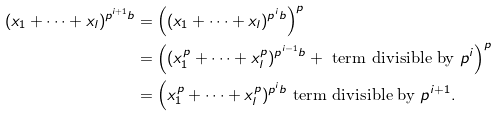<formula> <loc_0><loc_0><loc_500><loc_500>( x _ { 1 } + \cdots + x _ { l } ) ^ { p ^ { i + 1 } b } & = \Big ( ( x _ { 1 } + \cdots + x _ { l } ) ^ { p ^ { i } b } \Big ) ^ { p } \\ & = \Big ( ( x _ { 1 } ^ { p } + \cdots + x _ { l } ^ { p } ) ^ { p ^ { i - 1 } b } + \text { term divisible by } p ^ { i } \Big ) ^ { p } \\ & = \Big ( x _ { 1 } ^ { p } + \cdots + x _ { l } ^ { p } ) ^ { p ^ { i } b } \text { term divisible by } p ^ { i + 1 } .</formula> 